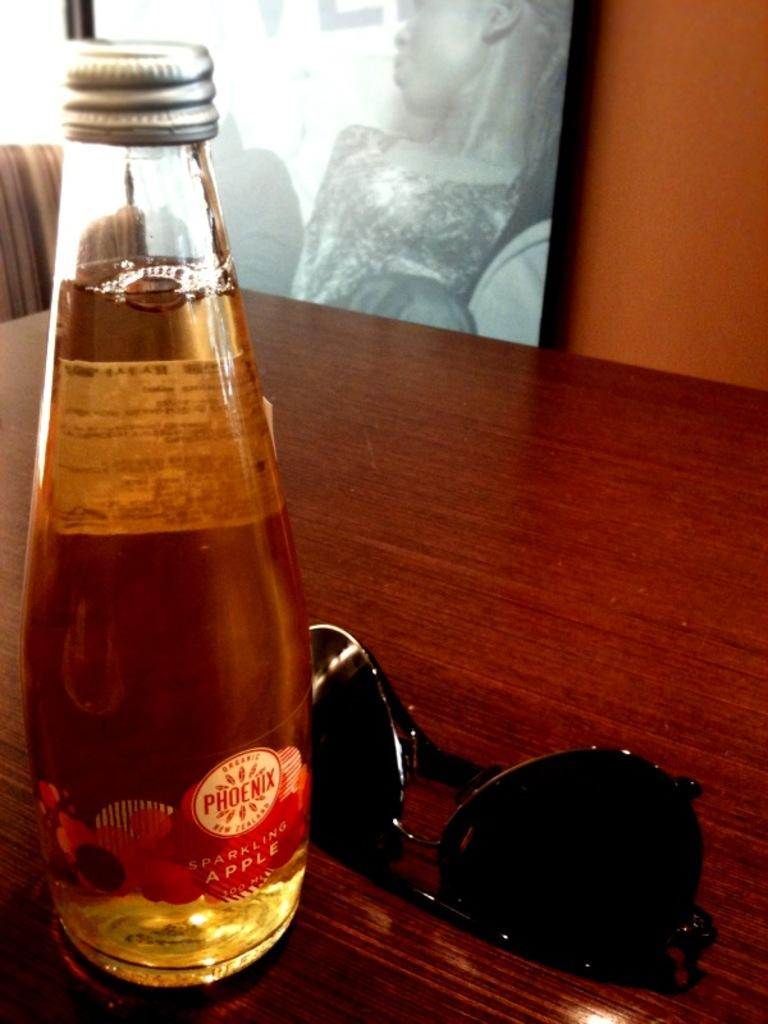<image>
Share a concise interpretation of the image provided. A bottle of Phoenix sparkling apple is sitting on a table in front of sunglasses. 